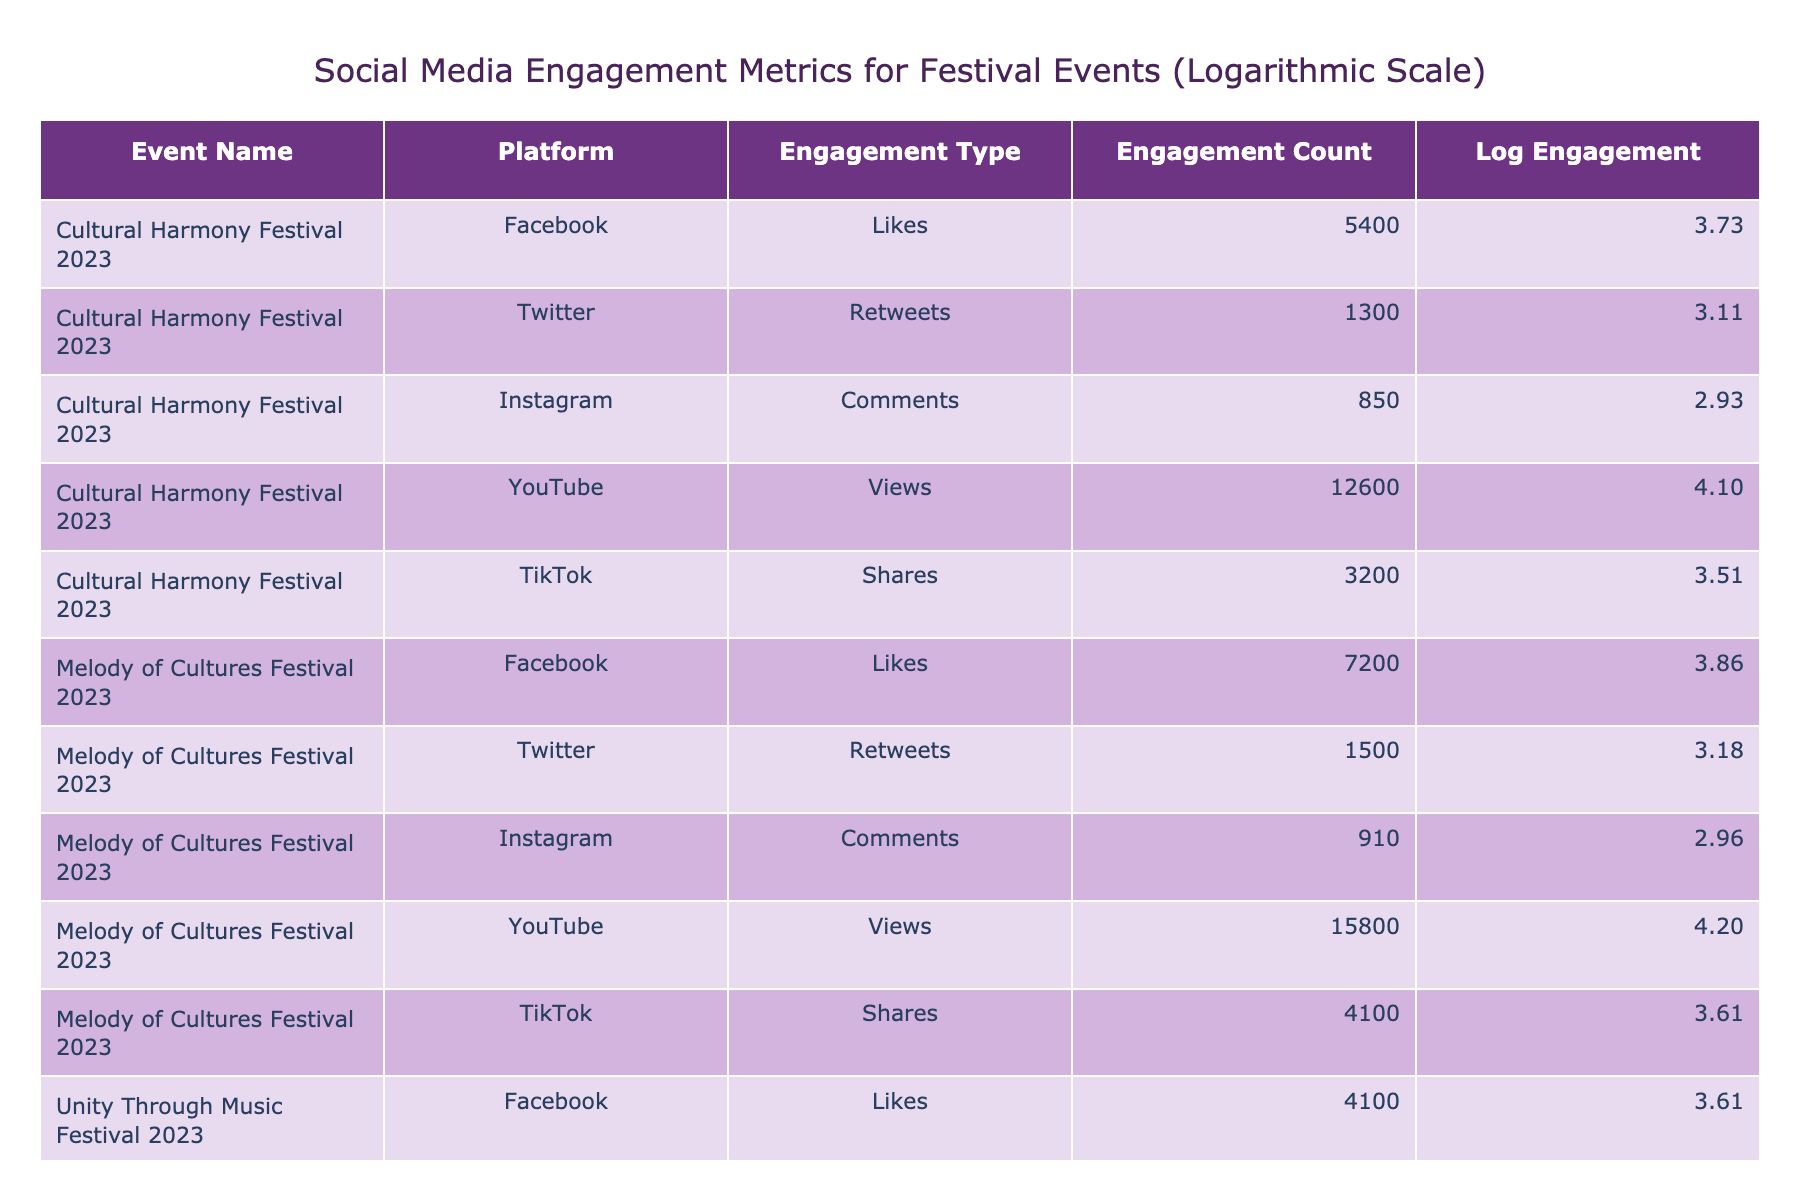What is the highest engagement count across all events? The highest engagement count can be found by looking at the "Engagement Count" column, which shows that the "Melody of Cultures Festival 2023" on YouTube has the highest value of 15800.
Answer: 15800 What is the total number of Likes across all Facebook posts? To calculate the total Likes, I sum the Engagement Counts for the Facebook Likes: 5400 (Cultural Harmony Festival) + 7200 (Melody of Cultures Festival) + 4100 (Unity Through Music Festival) = 16700.
Answer: 16700 Which festival had the lowest number of Comments on Instagram? By examining the Instagram Comments counts, "Unity Through Music Festival 2023" has the lowest count at 780.
Answer: 780 Is there a festival that had more Shares on TikTok than Retweets on Twitter? Yes, for each festival, I compare TikTok Shares and Twitter Retweets. "Melody of Cultures Festival 2023" had 4100 Shares (TikTok) and 1500 Retweets (Twitter), confirming that it is true.
Answer: Yes What is the average engagement count for YouTube across all festivals? The YouTube engagement counts are 12600, 15800, and 9500. The average is calculated by summing these values (12600 + 15800 + 9500 = 37900) and dividing by 3, resulting in an average of 12633.33.
Answer: 12633.33 Which platform had the highest overall engagement count in total? To determine this, I sum engagement counts for each platform: Facebook (5400 + 7200 + 4100 = 16700), Twitter (1300 + 1500 + 1100 = 3900), Instagram (850 + 910 + 780 = 2540), YouTube (12600 + 15800 + 9500 = 37900), and TikTok (3200 + 4100 + 2700 = 10000). YouTube has the highest total engagement of 37900.
Answer: YouTube What is the difference in engagement count between the Cultural Harmony Festival on YouTube and the Unity Through Music Festival on TikTok? For the Cultural Harmony Festival on YouTube, the engagement count is 12600, and for the Unity Through Music Festival on TikTok, it's 2700. The difference is calculated by subtracting TikTok's count from YouTube's: 12600 - 2700 = 9900.
Answer: 9900 Did any festival achieve over 1000 Retweets on Twitter? Yes, both the "Cultural Harmony Festival 2023" with 1300 Retweets and "Melody of Cultures Festival 2023" with 1500 Retweets achieved counts over 1000.
Answer: Yes What is the total engagement count for TikTok across all events? By summing the TikTok engagement counts: 3200 (Cultural Harmony Festival) + 4100 (Melody of Cultures Festival) + 2700 (Unity Through Music Festival) = 10000.
Answer: 10000 